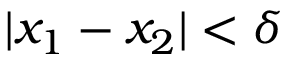<formula> <loc_0><loc_0><loc_500><loc_500>| x _ { 1 } - x _ { 2 } | < \delta</formula> 